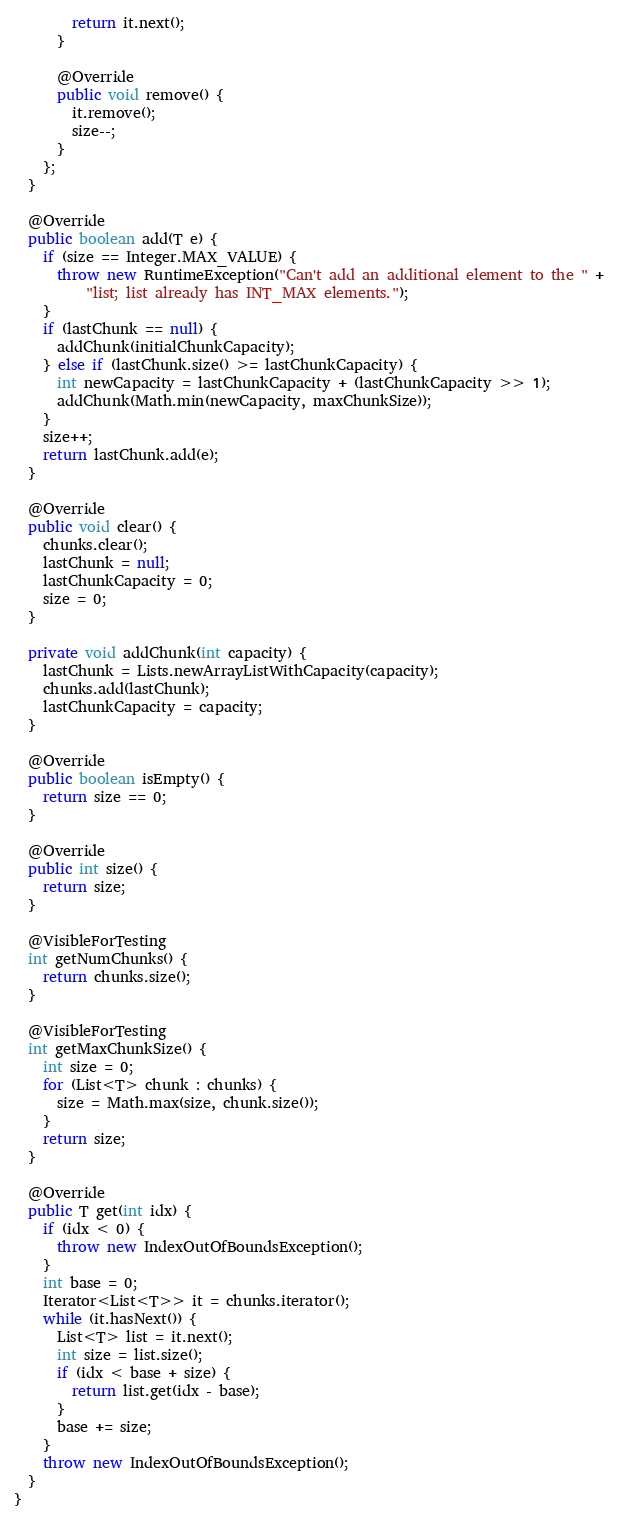Convert code to text. <code><loc_0><loc_0><loc_500><loc_500><_Java_>        return it.next();
      }

      @Override
      public void remove() {
        it.remove();
        size--;
      }
    };
  }

  @Override
  public boolean add(T e) {
    if (size == Integer.MAX_VALUE) {
      throw new RuntimeException("Can't add an additional element to the " +
          "list; list already has INT_MAX elements.");
    }
    if (lastChunk == null) {
      addChunk(initialChunkCapacity);
    } else if (lastChunk.size() >= lastChunkCapacity) {
      int newCapacity = lastChunkCapacity + (lastChunkCapacity >> 1);
      addChunk(Math.min(newCapacity, maxChunkSize));
    }
    size++;
    return lastChunk.add(e);
  }

  @Override
  public void clear() {
    chunks.clear();
    lastChunk = null;
    lastChunkCapacity = 0;
    size = 0;
  }
  
  private void addChunk(int capacity) {
    lastChunk = Lists.newArrayListWithCapacity(capacity);
    chunks.add(lastChunk);
    lastChunkCapacity = capacity;
  }

  @Override
  public boolean isEmpty() {
    return size == 0;
  }

  @Override
  public int size() {
    return size;
  }
  
  @VisibleForTesting
  int getNumChunks() {
    return chunks.size();
  }
  
  @VisibleForTesting
  int getMaxChunkSize() {
    int size = 0;
    for (List<T> chunk : chunks) {
      size = Math.max(size, chunk.size());
    }
    return size;
  }

  @Override
  public T get(int idx) {
    if (idx < 0) {
      throw new IndexOutOfBoundsException();
    }
    int base = 0;
    Iterator<List<T>> it = chunks.iterator();
    while (it.hasNext()) {
      List<T> list = it.next();
      int size = list.size();
      if (idx < base + size) {
        return list.get(idx - base);
      }
      base += size;
    }
    throw new IndexOutOfBoundsException();
  }
}
</code> 